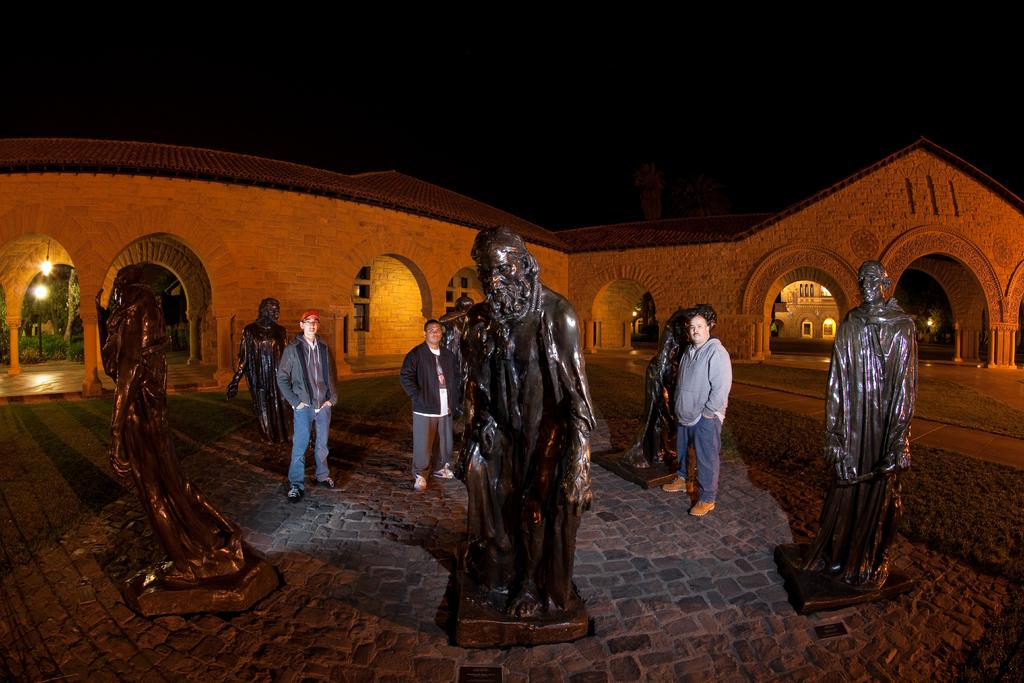What are the persons in the image doing? The persons in the image are standing beside statues. How are the statues positioned in the image? The statues are placed on the floor. What can be seen in the background of the image? There is a building, electric lights, and the sky visible in the background of the image. Where is the faucet located in the image? There is no faucet present in the image. What type of toy can be seen in the hands of the persons standing beside the statues? There are no toys visible in the image; the persons are standing beside statues. 